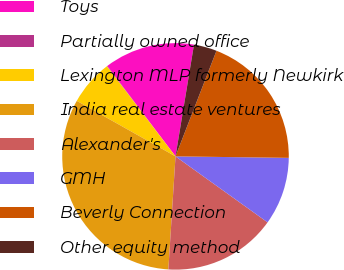Convert chart to OTSL. <chart><loc_0><loc_0><loc_500><loc_500><pie_chart><fcel>Toys<fcel>Partially owned office<fcel>Lexington MLP formerly Newkirk<fcel>India real estate ventures<fcel>Alexander's<fcel>GMH<fcel>Beverly Connection<fcel>Other equity method<nl><fcel>12.9%<fcel>0.07%<fcel>6.49%<fcel>32.15%<fcel>16.11%<fcel>9.69%<fcel>19.32%<fcel>3.28%<nl></chart> 